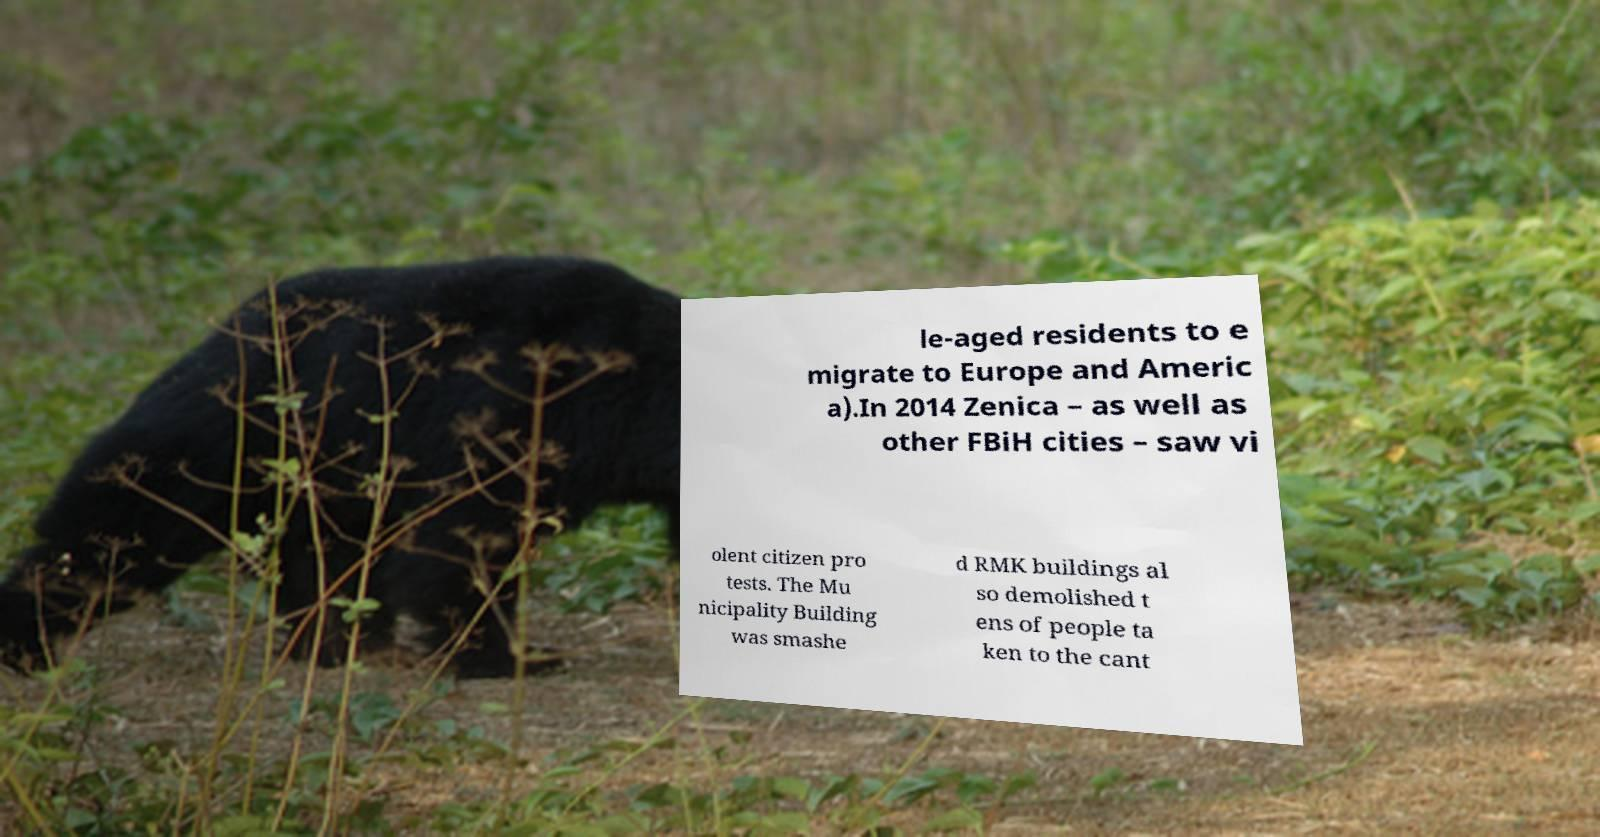Could you extract and type out the text from this image? le-aged residents to e migrate to Europe and Americ a).In 2014 Zenica – as well as other FBiH cities – saw vi olent citizen pro tests. The Mu nicipality Building was smashe d RMK buildings al so demolished t ens of people ta ken to the cant 